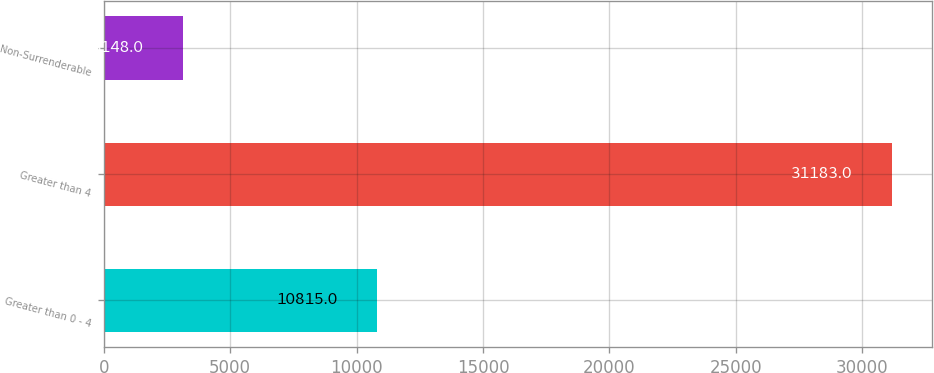<chart> <loc_0><loc_0><loc_500><loc_500><bar_chart><fcel>Greater than 0 - 4<fcel>Greater than 4<fcel>Non-Surrenderable<nl><fcel>10815<fcel>31183<fcel>3148<nl></chart> 